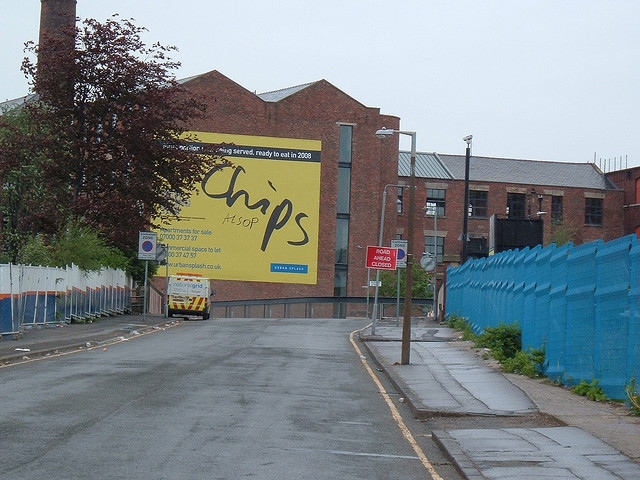<image>What color is the satellite dish? I don't know what color the satellite dish is. It might not be visible in the image. However, it could be white, gray, or silver. What color is the satellite dish? I don't know what color is the satellite dish. It can be seen as white, gray or silver. 